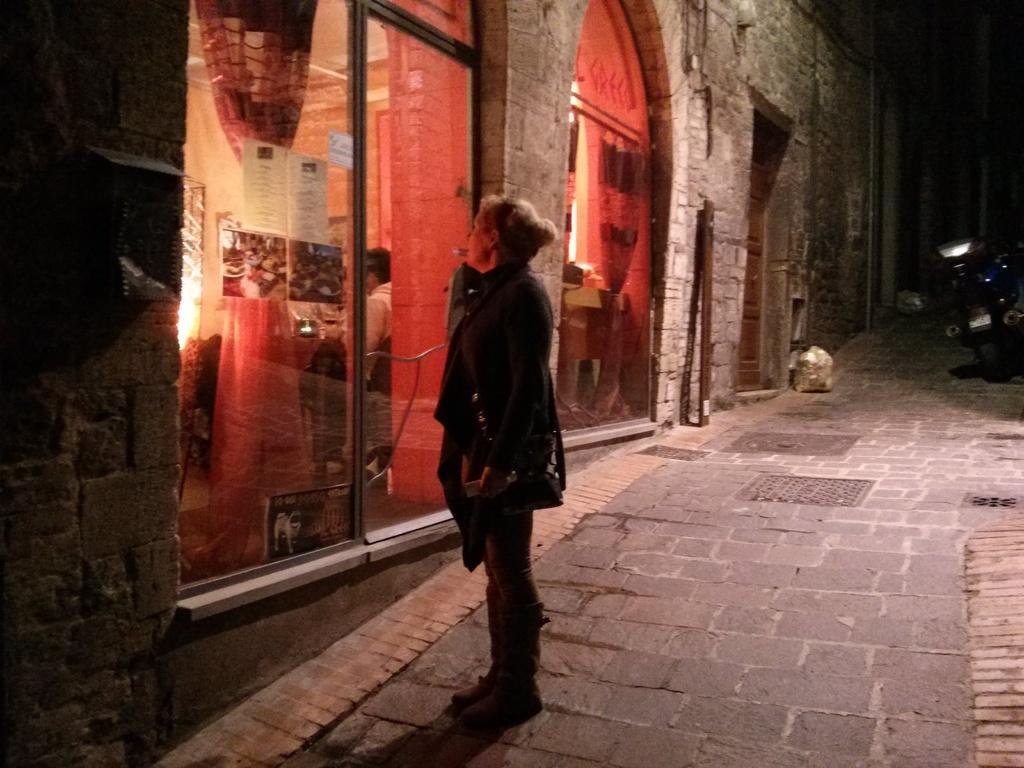How would you summarize this image in a sentence or two? In this image there is a woman standing on a pavement, in the background there is a building for that building there are glass doors and there is a bike on the pavement. 